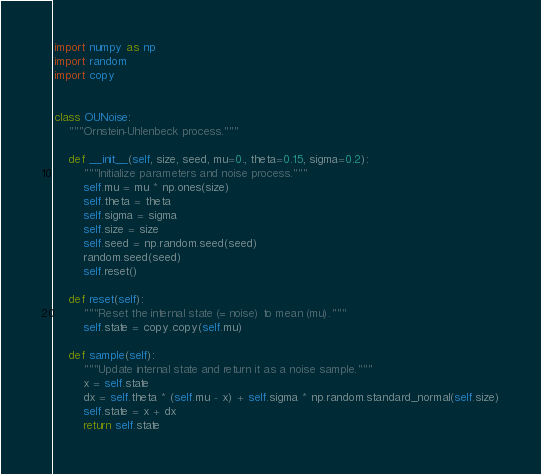<code> <loc_0><loc_0><loc_500><loc_500><_Python_>import numpy as np
import random
import copy


class OUNoise:
    """Ornstein-Uhlenbeck process."""

    def __init__(self, size, seed, mu=0., theta=0.15, sigma=0.2):
        """Initialize parameters and noise process."""
        self.mu = mu * np.ones(size)
        self.theta = theta
        self.sigma = sigma
        self.size = size
        self.seed = np.random.seed(seed)
        random.seed(seed)
        self.reset()

    def reset(self):
        """Reset the internal state (= noise) to mean (mu)."""
        self.state = copy.copy(self.mu)

    def sample(self):
        """Update internal state and return it as a noise sample."""
        x = self.state
        dx = self.theta * (self.mu - x) + self.sigma * np.random.standard_normal(self.size)
        self.state = x + dx
        return self.state
</code> 